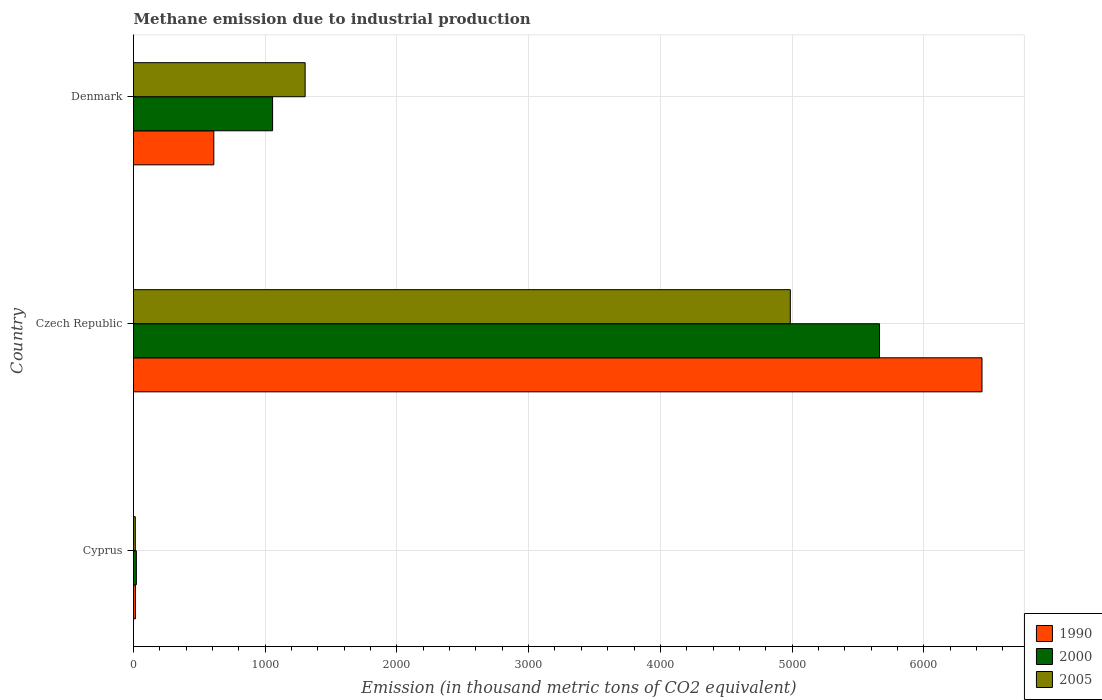How many different coloured bars are there?
Give a very brief answer. 3. Are the number of bars per tick equal to the number of legend labels?
Give a very brief answer. Yes. How many bars are there on the 2nd tick from the top?
Your response must be concise. 3. How many bars are there on the 2nd tick from the bottom?
Provide a succinct answer. 3. In how many cases, is the number of bars for a given country not equal to the number of legend labels?
Give a very brief answer. 0. Across all countries, what is the maximum amount of methane emitted in 1990?
Ensure brevity in your answer.  6442.2. Across all countries, what is the minimum amount of methane emitted in 2000?
Offer a very short reply. 21.7. In which country was the amount of methane emitted in 2000 maximum?
Your response must be concise. Czech Republic. In which country was the amount of methane emitted in 2005 minimum?
Keep it short and to the point. Cyprus. What is the total amount of methane emitted in 2005 in the graph?
Provide a succinct answer. 6303.7. What is the difference between the amount of methane emitted in 2000 in Cyprus and that in Denmark?
Give a very brief answer. -1034.3. What is the difference between the amount of methane emitted in 2005 in Czech Republic and the amount of methane emitted in 2000 in Cyprus?
Your answer should be very brief. 4965.2. What is the average amount of methane emitted in 2000 per country?
Keep it short and to the point. 2247.3. What is the difference between the amount of methane emitted in 2000 and amount of methane emitted in 2005 in Cyprus?
Your answer should be very brief. 8. In how many countries, is the amount of methane emitted in 1990 greater than 5800 thousand metric tons?
Your answer should be very brief. 1. What is the ratio of the amount of methane emitted in 2005 in Cyprus to that in Denmark?
Provide a short and direct response. 0.01. Is the difference between the amount of methane emitted in 2000 in Czech Republic and Denmark greater than the difference between the amount of methane emitted in 2005 in Czech Republic and Denmark?
Offer a very short reply. Yes. What is the difference between the highest and the second highest amount of methane emitted in 2000?
Make the answer very short. 4608.2. What is the difference between the highest and the lowest amount of methane emitted in 2000?
Offer a very short reply. 5642.5. Is it the case that in every country, the sum of the amount of methane emitted in 1990 and amount of methane emitted in 2000 is greater than the amount of methane emitted in 2005?
Your response must be concise. Yes. Does the graph contain any zero values?
Provide a succinct answer. No. What is the title of the graph?
Your answer should be compact. Methane emission due to industrial production. Does "1964" appear as one of the legend labels in the graph?
Provide a succinct answer. No. What is the label or title of the X-axis?
Your answer should be very brief. Emission (in thousand metric tons of CO2 equivalent). What is the Emission (in thousand metric tons of CO2 equivalent) of 2000 in Cyprus?
Give a very brief answer. 21.7. What is the Emission (in thousand metric tons of CO2 equivalent) in 2005 in Cyprus?
Make the answer very short. 13.7. What is the Emission (in thousand metric tons of CO2 equivalent) in 1990 in Czech Republic?
Provide a short and direct response. 6442.2. What is the Emission (in thousand metric tons of CO2 equivalent) of 2000 in Czech Republic?
Ensure brevity in your answer.  5664.2. What is the Emission (in thousand metric tons of CO2 equivalent) of 2005 in Czech Republic?
Your response must be concise. 4986.9. What is the Emission (in thousand metric tons of CO2 equivalent) in 1990 in Denmark?
Give a very brief answer. 609.7. What is the Emission (in thousand metric tons of CO2 equivalent) of 2000 in Denmark?
Provide a short and direct response. 1056. What is the Emission (in thousand metric tons of CO2 equivalent) in 2005 in Denmark?
Offer a terse response. 1303.1. Across all countries, what is the maximum Emission (in thousand metric tons of CO2 equivalent) in 1990?
Keep it short and to the point. 6442.2. Across all countries, what is the maximum Emission (in thousand metric tons of CO2 equivalent) of 2000?
Your answer should be compact. 5664.2. Across all countries, what is the maximum Emission (in thousand metric tons of CO2 equivalent) of 2005?
Make the answer very short. 4986.9. Across all countries, what is the minimum Emission (in thousand metric tons of CO2 equivalent) in 1990?
Ensure brevity in your answer.  14.7. Across all countries, what is the minimum Emission (in thousand metric tons of CO2 equivalent) in 2000?
Provide a succinct answer. 21.7. Across all countries, what is the minimum Emission (in thousand metric tons of CO2 equivalent) of 2005?
Provide a short and direct response. 13.7. What is the total Emission (in thousand metric tons of CO2 equivalent) of 1990 in the graph?
Your answer should be compact. 7066.6. What is the total Emission (in thousand metric tons of CO2 equivalent) in 2000 in the graph?
Provide a succinct answer. 6741.9. What is the total Emission (in thousand metric tons of CO2 equivalent) of 2005 in the graph?
Provide a succinct answer. 6303.7. What is the difference between the Emission (in thousand metric tons of CO2 equivalent) of 1990 in Cyprus and that in Czech Republic?
Provide a short and direct response. -6427.5. What is the difference between the Emission (in thousand metric tons of CO2 equivalent) in 2000 in Cyprus and that in Czech Republic?
Provide a succinct answer. -5642.5. What is the difference between the Emission (in thousand metric tons of CO2 equivalent) in 2005 in Cyprus and that in Czech Republic?
Offer a very short reply. -4973.2. What is the difference between the Emission (in thousand metric tons of CO2 equivalent) in 1990 in Cyprus and that in Denmark?
Your answer should be very brief. -595. What is the difference between the Emission (in thousand metric tons of CO2 equivalent) in 2000 in Cyprus and that in Denmark?
Provide a succinct answer. -1034.3. What is the difference between the Emission (in thousand metric tons of CO2 equivalent) of 2005 in Cyprus and that in Denmark?
Provide a succinct answer. -1289.4. What is the difference between the Emission (in thousand metric tons of CO2 equivalent) of 1990 in Czech Republic and that in Denmark?
Give a very brief answer. 5832.5. What is the difference between the Emission (in thousand metric tons of CO2 equivalent) in 2000 in Czech Republic and that in Denmark?
Provide a succinct answer. 4608.2. What is the difference between the Emission (in thousand metric tons of CO2 equivalent) in 2005 in Czech Republic and that in Denmark?
Provide a succinct answer. 3683.8. What is the difference between the Emission (in thousand metric tons of CO2 equivalent) in 1990 in Cyprus and the Emission (in thousand metric tons of CO2 equivalent) in 2000 in Czech Republic?
Make the answer very short. -5649.5. What is the difference between the Emission (in thousand metric tons of CO2 equivalent) in 1990 in Cyprus and the Emission (in thousand metric tons of CO2 equivalent) in 2005 in Czech Republic?
Keep it short and to the point. -4972.2. What is the difference between the Emission (in thousand metric tons of CO2 equivalent) of 2000 in Cyprus and the Emission (in thousand metric tons of CO2 equivalent) of 2005 in Czech Republic?
Offer a very short reply. -4965.2. What is the difference between the Emission (in thousand metric tons of CO2 equivalent) in 1990 in Cyprus and the Emission (in thousand metric tons of CO2 equivalent) in 2000 in Denmark?
Your answer should be very brief. -1041.3. What is the difference between the Emission (in thousand metric tons of CO2 equivalent) of 1990 in Cyprus and the Emission (in thousand metric tons of CO2 equivalent) of 2005 in Denmark?
Offer a terse response. -1288.4. What is the difference between the Emission (in thousand metric tons of CO2 equivalent) of 2000 in Cyprus and the Emission (in thousand metric tons of CO2 equivalent) of 2005 in Denmark?
Give a very brief answer. -1281.4. What is the difference between the Emission (in thousand metric tons of CO2 equivalent) in 1990 in Czech Republic and the Emission (in thousand metric tons of CO2 equivalent) in 2000 in Denmark?
Make the answer very short. 5386.2. What is the difference between the Emission (in thousand metric tons of CO2 equivalent) of 1990 in Czech Republic and the Emission (in thousand metric tons of CO2 equivalent) of 2005 in Denmark?
Your answer should be very brief. 5139.1. What is the difference between the Emission (in thousand metric tons of CO2 equivalent) in 2000 in Czech Republic and the Emission (in thousand metric tons of CO2 equivalent) in 2005 in Denmark?
Give a very brief answer. 4361.1. What is the average Emission (in thousand metric tons of CO2 equivalent) of 1990 per country?
Offer a very short reply. 2355.53. What is the average Emission (in thousand metric tons of CO2 equivalent) of 2000 per country?
Keep it short and to the point. 2247.3. What is the average Emission (in thousand metric tons of CO2 equivalent) in 2005 per country?
Give a very brief answer. 2101.23. What is the difference between the Emission (in thousand metric tons of CO2 equivalent) in 1990 and Emission (in thousand metric tons of CO2 equivalent) in 2005 in Cyprus?
Offer a terse response. 1. What is the difference between the Emission (in thousand metric tons of CO2 equivalent) of 2000 and Emission (in thousand metric tons of CO2 equivalent) of 2005 in Cyprus?
Ensure brevity in your answer.  8. What is the difference between the Emission (in thousand metric tons of CO2 equivalent) in 1990 and Emission (in thousand metric tons of CO2 equivalent) in 2000 in Czech Republic?
Offer a terse response. 778. What is the difference between the Emission (in thousand metric tons of CO2 equivalent) in 1990 and Emission (in thousand metric tons of CO2 equivalent) in 2005 in Czech Republic?
Your answer should be compact. 1455.3. What is the difference between the Emission (in thousand metric tons of CO2 equivalent) in 2000 and Emission (in thousand metric tons of CO2 equivalent) in 2005 in Czech Republic?
Offer a very short reply. 677.3. What is the difference between the Emission (in thousand metric tons of CO2 equivalent) in 1990 and Emission (in thousand metric tons of CO2 equivalent) in 2000 in Denmark?
Ensure brevity in your answer.  -446.3. What is the difference between the Emission (in thousand metric tons of CO2 equivalent) of 1990 and Emission (in thousand metric tons of CO2 equivalent) of 2005 in Denmark?
Provide a short and direct response. -693.4. What is the difference between the Emission (in thousand metric tons of CO2 equivalent) of 2000 and Emission (in thousand metric tons of CO2 equivalent) of 2005 in Denmark?
Offer a terse response. -247.1. What is the ratio of the Emission (in thousand metric tons of CO2 equivalent) of 1990 in Cyprus to that in Czech Republic?
Your answer should be very brief. 0. What is the ratio of the Emission (in thousand metric tons of CO2 equivalent) in 2000 in Cyprus to that in Czech Republic?
Your answer should be compact. 0. What is the ratio of the Emission (in thousand metric tons of CO2 equivalent) in 2005 in Cyprus to that in Czech Republic?
Make the answer very short. 0. What is the ratio of the Emission (in thousand metric tons of CO2 equivalent) in 1990 in Cyprus to that in Denmark?
Give a very brief answer. 0.02. What is the ratio of the Emission (in thousand metric tons of CO2 equivalent) of 2000 in Cyprus to that in Denmark?
Provide a succinct answer. 0.02. What is the ratio of the Emission (in thousand metric tons of CO2 equivalent) of 2005 in Cyprus to that in Denmark?
Your answer should be very brief. 0.01. What is the ratio of the Emission (in thousand metric tons of CO2 equivalent) in 1990 in Czech Republic to that in Denmark?
Provide a short and direct response. 10.57. What is the ratio of the Emission (in thousand metric tons of CO2 equivalent) in 2000 in Czech Republic to that in Denmark?
Your answer should be very brief. 5.36. What is the ratio of the Emission (in thousand metric tons of CO2 equivalent) in 2005 in Czech Republic to that in Denmark?
Make the answer very short. 3.83. What is the difference between the highest and the second highest Emission (in thousand metric tons of CO2 equivalent) of 1990?
Make the answer very short. 5832.5. What is the difference between the highest and the second highest Emission (in thousand metric tons of CO2 equivalent) in 2000?
Make the answer very short. 4608.2. What is the difference between the highest and the second highest Emission (in thousand metric tons of CO2 equivalent) of 2005?
Provide a short and direct response. 3683.8. What is the difference between the highest and the lowest Emission (in thousand metric tons of CO2 equivalent) of 1990?
Provide a succinct answer. 6427.5. What is the difference between the highest and the lowest Emission (in thousand metric tons of CO2 equivalent) of 2000?
Your answer should be compact. 5642.5. What is the difference between the highest and the lowest Emission (in thousand metric tons of CO2 equivalent) of 2005?
Offer a terse response. 4973.2. 